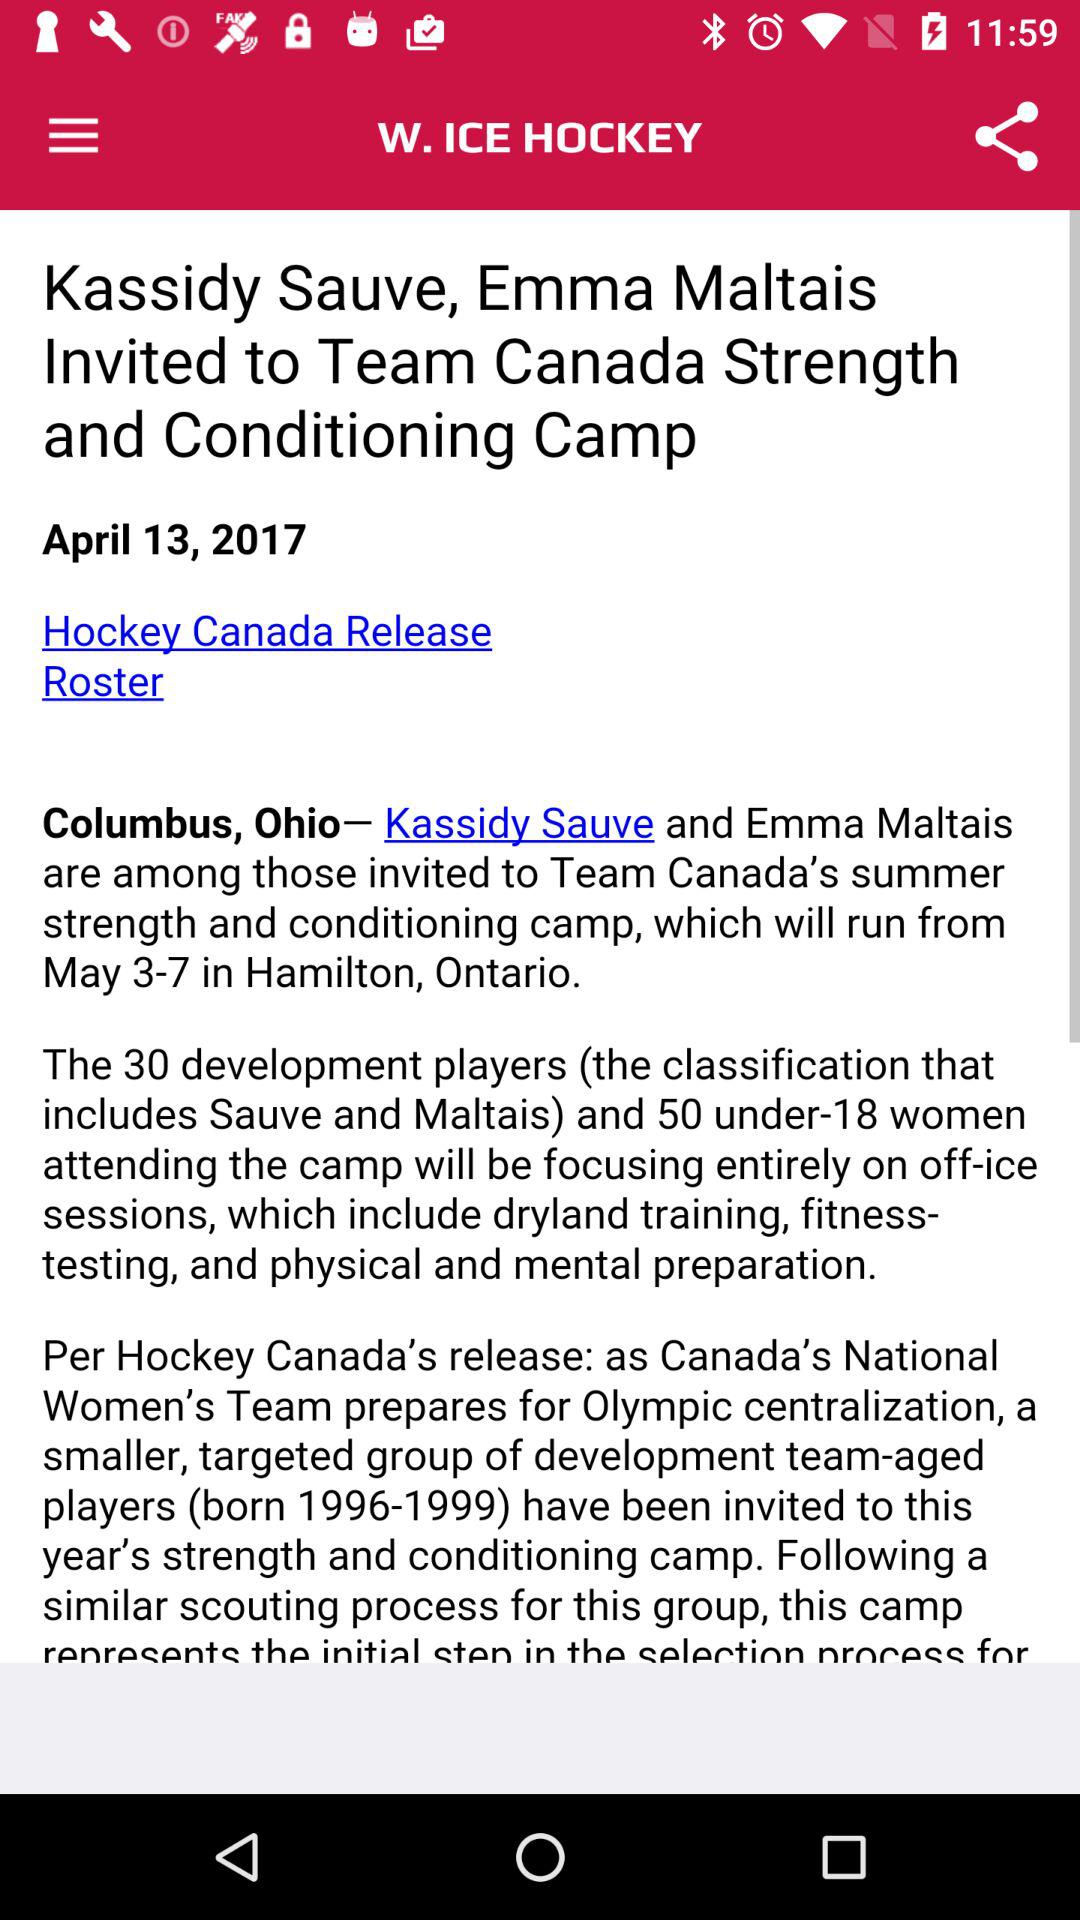How many players are invited to the camp?
Answer the question using a single word or phrase. 80 